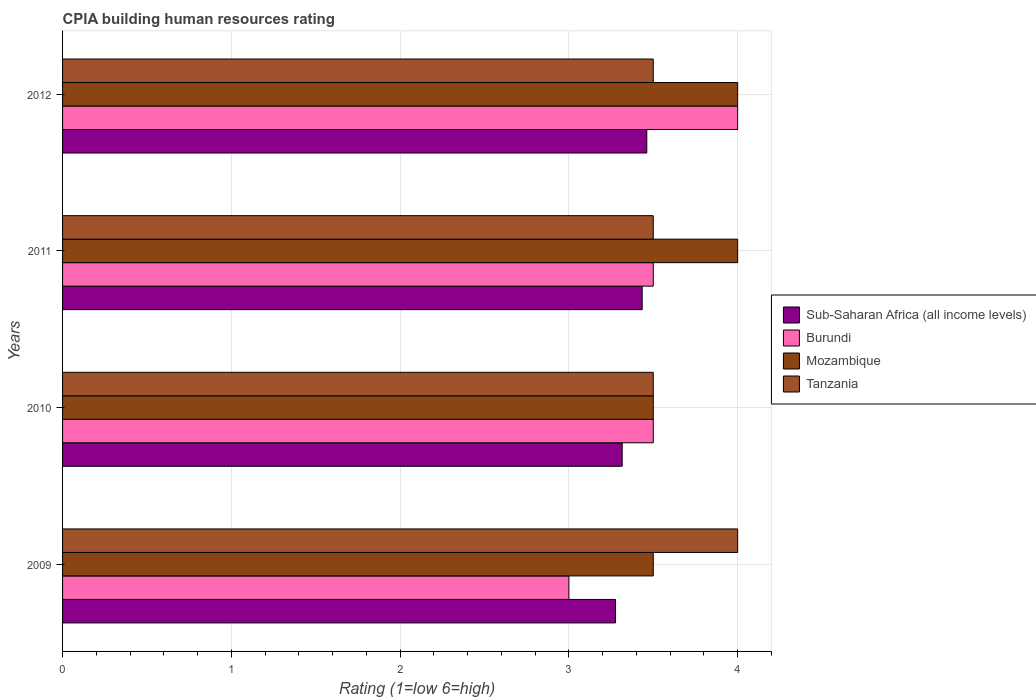How many different coloured bars are there?
Offer a very short reply. 4. How many groups of bars are there?
Offer a terse response. 4. How many bars are there on the 2nd tick from the top?
Offer a very short reply. 4. What is the label of the 2nd group of bars from the top?
Offer a terse response. 2011. In how many cases, is the number of bars for a given year not equal to the number of legend labels?
Offer a very short reply. 0. Across all years, what is the maximum CPIA rating in Sub-Saharan Africa (all income levels)?
Provide a short and direct response. 3.46. Across all years, what is the minimum CPIA rating in Tanzania?
Your response must be concise. 3.5. In which year was the CPIA rating in Sub-Saharan Africa (all income levels) minimum?
Your answer should be very brief. 2009. What is the total CPIA rating in Mozambique in the graph?
Offer a very short reply. 15. In the year 2012, what is the difference between the CPIA rating in Burundi and CPIA rating in Sub-Saharan Africa (all income levels)?
Offer a very short reply. 0.54. What is the ratio of the CPIA rating in Tanzania in 2009 to that in 2012?
Your answer should be compact. 1.14. What is the difference between the highest and the lowest CPIA rating in Sub-Saharan Africa (all income levels)?
Your answer should be compact. 0.19. What does the 3rd bar from the top in 2010 represents?
Your response must be concise. Burundi. What does the 2nd bar from the bottom in 2012 represents?
Offer a very short reply. Burundi. How many years are there in the graph?
Provide a succinct answer. 4. Does the graph contain any zero values?
Provide a succinct answer. No. Does the graph contain grids?
Keep it short and to the point. Yes. Where does the legend appear in the graph?
Ensure brevity in your answer.  Center right. How many legend labels are there?
Provide a short and direct response. 4. What is the title of the graph?
Offer a very short reply. CPIA building human resources rating. What is the label or title of the X-axis?
Make the answer very short. Rating (1=low 6=high). What is the Rating (1=low 6=high) in Sub-Saharan Africa (all income levels) in 2009?
Provide a succinct answer. 3.28. What is the Rating (1=low 6=high) in Mozambique in 2009?
Your answer should be very brief. 3.5. What is the Rating (1=low 6=high) of Tanzania in 2009?
Your answer should be very brief. 4. What is the Rating (1=low 6=high) of Sub-Saharan Africa (all income levels) in 2010?
Your response must be concise. 3.32. What is the Rating (1=low 6=high) in Burundi in 2010?
Your response must be concise. 3.5. What is the Rating (1=low 6=high) in Sub-Saharan Africa (all income levels) in 2011?
Your answer should be very brief. 3.43. What is the Rating (1=low 6=high) in Burundi in 2011?
Make the answer very short. 3.5. What is the Rating (1=low 6=high) in Sub-Saharan Africa (all income levels) in 2012?
Provide a short and direct response. 3.46. What is the Rating (1=low 6=high) of Burundi in 2012?
Keep it short and to the point. 4. Across all years, what is the maximum Rating (1=low 6=high) of Sub-Saharan Africa (all income levels)?
Offer a very short reply. 3.46. Across all years, what is the maximum Rating (1=low 6=high) of Mozambique?
Provide a succinct answer. 4. Across all years, what is the maximum Rating (1=low 6=high) of Tanzania?
Your answer should be very brief. 4. Across all years, what is the minimum Rating (1=low 6=high) of Sub-Saharan Africa (all income levels)?
Provide a short and direct response. 3.28. Across all years, what is the minimum Rating (1=low 6=high) in Mozambique?
Offer a very short reply. 3.5. What is the total Rating (1=low 6=high) in Sub-Saharan Africa (all income levels) in the graph?
Your answer should be very brief. 13.49. What is the total Rating (1=low 6=high) of Burundi in the graph?
Offer a terse response. 14. What is the total Rating (1=low 6=high) of Tanzania in the graph?
Offer a terse response. 14.5. What is the difference between the Rating (1=low 6=high) in Sub-Saharan Africa (all income levels) in 2009 and that in 2010?
Your response must be concise. -0.04. What is the difference between the Rating (1=low 6=high) in Tanzania in 2009 and that in 2010?
Give a very brief answer. 0.5. What is the difference between the Rating (1=low 6=high) of Sub-Saharan Africa (all income levels) in 2009 and that in 2011?
Your answer should be very brief. -0.16. What is the difference between the Rating (1=low 6=high) of Burundi in 2009 and that in 2011?
Your response must be concise. -0.5. What is the difference between the Rating (1=low 6=high) of Mozambique in 2009 and that in 2011?
Offer a terse response. -0.5. What is the difference between the Rating (1=low 6=high) of Tanzania in 2009 and that in 2011?
Your answer should be compact. 0.5. What is the difference between the Rating (1=low 6=high) of Sub-Saharan Africa (all income levels) in 2009 and that in 2012?
Keep it short and to the point. -0.19. What is the difference between the Rating (1=low 6=high) of Tanzania in 2009 and that in 2012?
Your answer should be very brief. 0.5. What is the difference between the Rating (1=low 6=high) in Sub-Saharan Africa (all income levels) in 2010 and that in 2011?
Keep it short and to the point. -0.12. What is the difference between the Rating (1=low 6=high) in Burundi in 2010 and that in 2011?
Your answer should be very brief. 0. What is the difference between the Rating (1=low 6=high) of Mozambique in 2010 and that in 2011?
Make the answer very short. -0.5. What is the difference between the Rating (1=low 6=high) of Tanzania in 2010 and that in 2011?
Offer a terse response. 0. What is the difference between the Rating (1=low 6=high) in Sub-Saharan Africa (all income levels) in 2010 and that in 2012?
Your answer should be compact. -0.15. What is the difference between the Rating (1=low 6=high) in Tanzania in 2010 and that in 2012?
Your answer should be compact. 0. What is the difference between the Rating (1=low 6=high) of Sub-Saharan Africa (all income levels) in 2011 and that in 2012?
Give a very brief answer. -0.03. What is the difference between the Rating (1=low 6=high) in Mozambique in 2011 and that in 2012?
Make the answer very short. 0. What is the difference between the Rating (1=low 6=high) of Sub-Saharan Africa (all income levels) in 2009 and the Rating (1=low 6=high) of Burundi in 2010?
Your answer should be very brief. -0.22. What is the difference between the Rating (1=low 6=high) in Sub-Saharan Africa (all income levels) in 2009 and the Rating (1=low 6=high) in Mozambique in 2010?
Ensure brevity in your answer.  -0.22. What is the difference between the Rating (1=low 6=high) of Sub-Saharan Africa (all income levels) in 2009 and the Rating (1=low 6=high) of Tanzania in 2010?
Provide a short and direct response. -0.22. What is the difference between the Rating (1=low 6=high) in Burundi in 2009 and the Rating (1=low 6=high) in Mozambique in 2010?
Your answer should be very brief. -0.5. What is the difference between the Rating (1=low 6=high) in Sub-Saharan Africa (all income levels) in 2009 and the Rating (1=low 6=high) in Burundi in 2011?
Ensure brevity in your answer.  -0.22. What is the difference between the Rating (1=low 6=high) in Sub-Saharan Africa (all income levels) in 2009 and the Rating (1=low 6=high) in Mozambique in 2011?
Your response must be concise. -0.72. What is the difference between the Rating (1=low 6=high) in Sub-Saharan Africa (all income levels) in 2009 and the Rating (1=low 6=high) in Tanzania in 2011?
Make the answer very short. -0.22. What is the difference between the Rating (1=low 6=high) of Burundi in 2009 and the Rating (1=low 6=high) of Tanzania in 2011?
Provide a short and direct response. -0.5. What is the difference between the Rating (1=low 6=high) of Sub-Saharan Africa (all income levels) in 2009 and the Rating (1=low 6=high) of Burundi in 2012?
Offer a very short reply. -0.72. What is the difference between the Rating (1=low 6=high) of Sub-Saharan Africa (all income levels) in 2009 and the Rating (1=low 6=high) of Mozambique in 2012?
Provide a short and direct response. -0.72. What is the difference between the Rating (1=low 6=high) in Sub-Saharan Africa (all income levels) in 2009 and the Rating (1=low 6=high) in Tanzania in 2012?
Your answer should be compact. -0.22. What is the difference between the Rating (1=low 6=high) of Sub-Saharan Africa (all income levels) in 2010 and the Rating (1=low 6=high) of Burundi in 2011?
Make the answer very short. -0.18. What is the difference between the Rating (1=low 6=high) of Sub-Saharan Africa (all income levels) in 2010 and the Rating (1=low 6=high) of Mozambique in 2011?
Your response must be concise. -0.68. What is the difference between the Rating (1=low 6=high) in Sub-Saharan Africa (all income levels) in 2010 and the Rating (1=low 6=high) in Tanzania in 2011?
Ensure brevity in your answer.  -0.18. What is the difference between the Rating (1=low 6=high) in Burundi in 2010 and the Rating (1=low 6=high) in Tanzania in 2011?
Make the answer very short. 0. What is the difference between the Rating (1=low 6=high) of Mozambique in 2010 and the Rating (1=low 6=high) of Tanzania in 2011?
Offer a very short reply. 0. What is the difference between the Rating (1=low 6=high) of Sub-Saharan Africa (all income levels) in 2010 and the Rating (1=low 6=high) of Burundi in 2012?
Your answer should be very brief. -0.68. What is the difference between the Rating (1=low 6=high) in Sub-Saharan Africa (all income levels) in 2010 and the Rating (1=low 6=high) in Mozambique in 2012?
Offer a very short reply. -0.68. What is the difference between the Rating (1=low 6=high) of Sub-Saharan Africa (all income levels) in 2010 and the Rating (1=low 6=high) of Tanzania in 2012?
Keep it short and to the point. -0.18. What is the difference between the Rating (1=low 6=high) of Burundi in 2010 and the Rating (1=low 6=high) of Mozambique in 2012?
Offer a terse response. -0.5. What is the difference between the Rating (1=low 6=high) in Mozambique in 2010 and the Rating (1=low 6=high) in Tanzania in 2012?
Your response must be concise. 0. What is the difference between the Rating (1=low 6=high) in Sub-Saharan Africa (all income levels) in 2011 and the Rating (1=low 6=high) in Burundi in 2012?
Make the answer very short. -0.57. What is the difference between the Rating (1=low 6=high) of Sub-Saharan Africa (all income levels) in 2011 and the Rating (1=low 6=high) of Mozambique in 2012?
Offer a very short reply. -0.57. What is the difference between the Rating (1=low 6=high) in Sub-Saharan Africa (all income levels) in 2011 and the Rating (1=low 6=high) in Tanzania in 2012?
Give a very brief answer. -0.07. What is the difference between the Rating (1=low 6=high) in Burundi in 2011 and the Rating (1=low 6=high) in Tanzania in 2012?
Offer a terse response. 0. What is the average Rating (1=low 6=high) in Sub-Saharan Africa (all income levels) per year?
Keep it short and to the point. 3.37. What is the average Rating (1=low 6=high) of Mozambique per year?
Provide a succinct answer. 3.75. What is the average Rating (1=low 6=high) in Tanzania per year?
Give a very brief answer. 3.62. In the year 2009, what is the difference between the Rating (1=low 6=high) of Sub-Saharan Africa (all income levels) and Rating (1=low 6=high) of Burundi?
Offer a terse response. 0.28. In the year 2009, what is the difference between the Rating (1=low 6=high) of Sub-Saharan Africa (all income levels) and Rating (1=low 6=high) of Mozambique?
Keep it short and to the point. -0.22. In the year 2009, what is the difference between the Rating (1=low 6=high) of Sub-Saharan Africa (all income levels) and Rating (1=low 6=high) of Tanzania?
Make the answer very short. -0.72. In the year 2009, what is the difference between the Rating (1=low 6=high) in Burundi and Rating (1=low 6=high) in Mozambique?
Give a very brief answer. -0.5. In the year 2009, what is the difference between the Rating (1=low 6=high) of Mozambique and Rating (1=low 6=high) of Tanzania?
Ensure brevity in your answer.  -0.5. In the year 2010, what is the difference between the Rating (1=low 6=high) of Sub-Saharan Africa (all income levels) and Rating (1=low 6=high) of Burundi?
Provide a short and direct response. -0.18. In the year 2010, what is the difference between the Rating (1=low 6=high) of Sub-Saharan Africa (all income levels) and Rating (1=low 6=high) of Mozambique?
Your response must be concise. -0.18. In the year 2010, what is the difference between the Rating (1=low 6=high) of Sub-Saharan Africa (all income levels) and Rating (1=low 6=high) of Tanzania?
Ensure brevity in your answer.  -0.18. In the year 2010, what is the difference between the Rating (1=low 6=high) in Burundi and Rating (1=low 6=high) in Mozambique?
Give a very brief answer. 0. In the year 2010, what is the difference between the Rating (1=low 6=high) of Mozambique and Rating (1=low 6=high) of Tanzania?
Give a very brief answer. 0. In the year 2011, what is the difference between the Rating (1=low 6=high) in Sub-Saharan Africa (all income levels) and Rating (1=low 6=high) in Burundi?
Keep it short and to the point. -0.07. In the year 2011, what is the difference between the Rating (1=low 6=high) of Sub-Saharan Africa (all income levels) and Rating (1=low 6=high) of Mozambique?
Ensure brevity in your answer.  -0.57. In the year 2011, what is the difference between the Rating (1=low 6=high) in Sub-Saharan Africa (all income levels) and Rating (1=low 6=high) in Tanzania?
Your answer should be very brief. -0.07. In the year 2011, what is the difference between the Rating (1=low 6=high) of Burundi and Rating (1=low 6=high) of Mozambique?
Keep it short and to the point. -0.5. In the year 2011, what is the difference between the Rating (1=low 6=high) in Burundi and Rating (1=low 6=high) in Tanzania?
Your answer should be very brief. 0. In the year 2012, what is the difference between the Rating (1=low 6=high) of Sub-Saharan Africa (all income levels) and Rating (1=low 6=high) of Burundi?
Ensure brevity in your answer.  -0.54. In the year 2012, what is the difference between the Rating (1=low 6=high) in Sub-Saharan Africa (all income levels) and Rating (1=low 6=high) in Mozambique?
Your answer should be compact. -0.54. In the year 2012, what is the difference between the Rating (1=low 6=high) of Sub-Saharan Africa (all income levels) and Rating (1=low 6=high) of Tanzania?
Offer a terse response. -0.04. In the year 2012, what is the difference between the Rating (1=low 6=high) in Burundi and Rating (1=low 6=high) in Mozambique?
Your answer should be compact. 0. What is the ratio of the Rating (1=low 6=high) of Burundi in 2009 to that in 2010?
Ensure brevity in your answer.  0.86. What is the ratio of the Rating (1=low 6=high) of Mozambique in 2009 to that in 2010?
Provide a succinct answer. 1. What is the ratio of the Rating (1=low 6=high) in Tanzania in 2009 to that in 2010?
Your response must be concise. 1.14. What is the ratio of the Rating (1=low 6=high) of Sub-Saharan Africa (all income levels) in 2009 to that in 2011?
Provide a succinct answer. 0.95. What is the ratio of the Rating (1=low 6=high) of Mozambique in 2009 to that in 2011?
Your answer should be very brief. 0.88. What is the ratio of the Rating (1=low 6=high) in Tanzania in 2009 to that in 2011?
Provide a succinct answer. 1.14. What is the ratio of the Rating (1=low 6=high) in Sub-Saharan Africa (all income levels) in 2009 to that in 2012?
Provide a short and direct response. 0.95. What is the ratio of the Rating (1=low 6=high) of Tanzania in 2009 to that in 2012?
Ensure brevity in your answer.  1.14. What is the ratio of the Rating (1=low 6=high) of Sub-Saharan Africa (all income levels) in 2010 to that in 2011?
Ensure brevity in your answer.  0.97. What is the ratio of the Rating (1=low 6=high) in Burundi in 2010 to that in 2011?
Your answer should be very brief. 1. What is the ratio of the Rating (1=low 6=high) in Sub-Saharan Africa (all income levels) in 2010 to that in 2012?
Give a very brief answer. 0.96. What is the ratio of the Rating (1=low 6=high) in Burundi in 2010 to that in 2012?
Your response must be concise. 0.88. What is the ratio of the Rating (1=low 6=high) in Sub-Saharan Africa (all income levels) in 2011 to that in 2012?
Provide a succinct answer. 0.99. What is the ratio of the Rating (1=low 6=high) of Mozambique in 2011 to that in 2012?
Your answer should be very brief. 1. What is the ratio of the Rating (1=low 6=high) in Tanzania in 2011 to that in 2012?
Ensure brevity in your answer.  1. What is the difference between the highest and the second highest Rating (1=low 6=high) in Sub-Saharan Africa (all income levels)?
Make the answer very short. 0.03. What is the difference between the highest and the lowest Rating (1=low 6=high) of Sub-Saharan Africa (all income levels)?
Ensure brevity in your answer.  0.19. What is the difference between the highest and the lowest Rating (1=low 6=high) in Mozambique?
Ensure brevity in your answer.  0.5. 